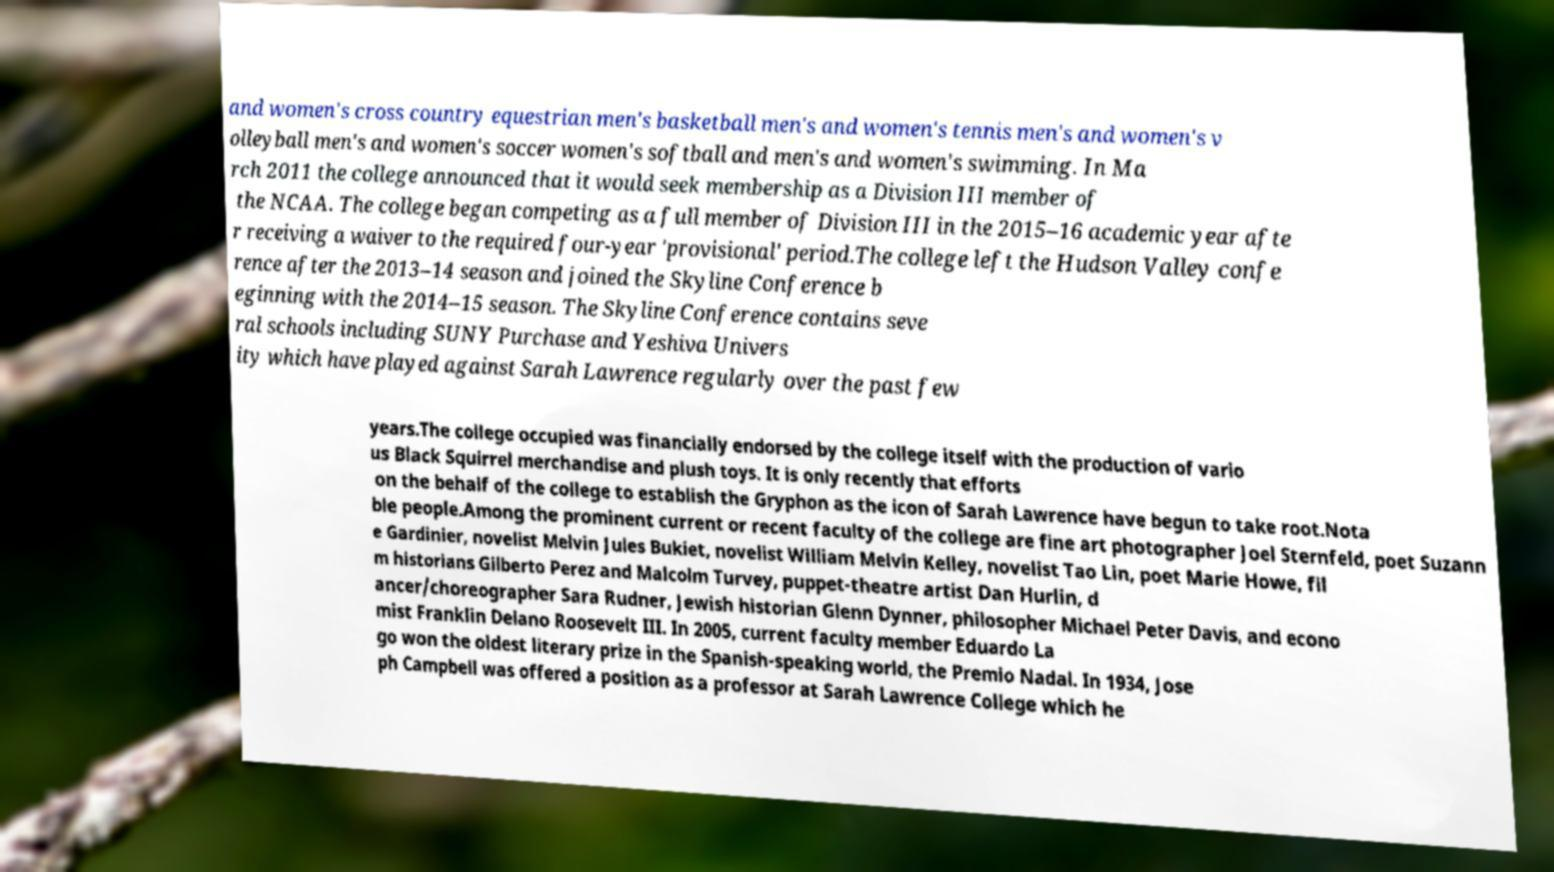Could you extract and type out the text from this image? and women's cross country equestrian men's basketball men's and women's tennis men's and women's v olleyball men's and women's soccer women's softball and men's and women's swimming. In Ma rch 2011 the college announced that it would seek membership as a Division III member of the NCAA. The college began competing as a full member of Division III in the 2015–16 academic year afte r receiving a waiver to the required four-year 'provisional' period.The college left the Hudson Valley confe rence after the 2013–14 season and joined the Skyline Conference b eginning with the 2014–15 season. The Skyline Conference contains seve ral schools including SUNY Purchase and Yeshiva Univers ity which have played against Sarah Lawrence regularly over the past few years.The college occupied was financially endorsed by the college itself with the production of vario us Black Squirrel merchandise and plush toys. It is only recently that efforts on the behalf of the college to establish the Gryphon as the icon of Sarah Lawrence have begun to take root.Nota ble people.Among the prominent current or recent faculty of the college are fine art photographer Joel Sternfeld, poet Suzann e Gardinier, novelist Melvin Jules Bukiet, novelist William Melvin Kelley, novelist Tao Lin, poet Marie Howe, fil m historians Gilberto Perez and Malcolm Turvey, puppet-theatre artist Dan Hurlin, d ancer/choreographer Sara Rudner, Jewish historian Glenn Dynner, philosopher Michael Peter Davis, and econo mist Franklin Delano Roosevelt III. In 2005, current faculty member Eduardo La go won the oldest literary prize in the Spanish-speaking world, the Premio Nadal. In 1934, Jose ph Campbell was offered a position as a professor at Sarah Lawrence College which he 